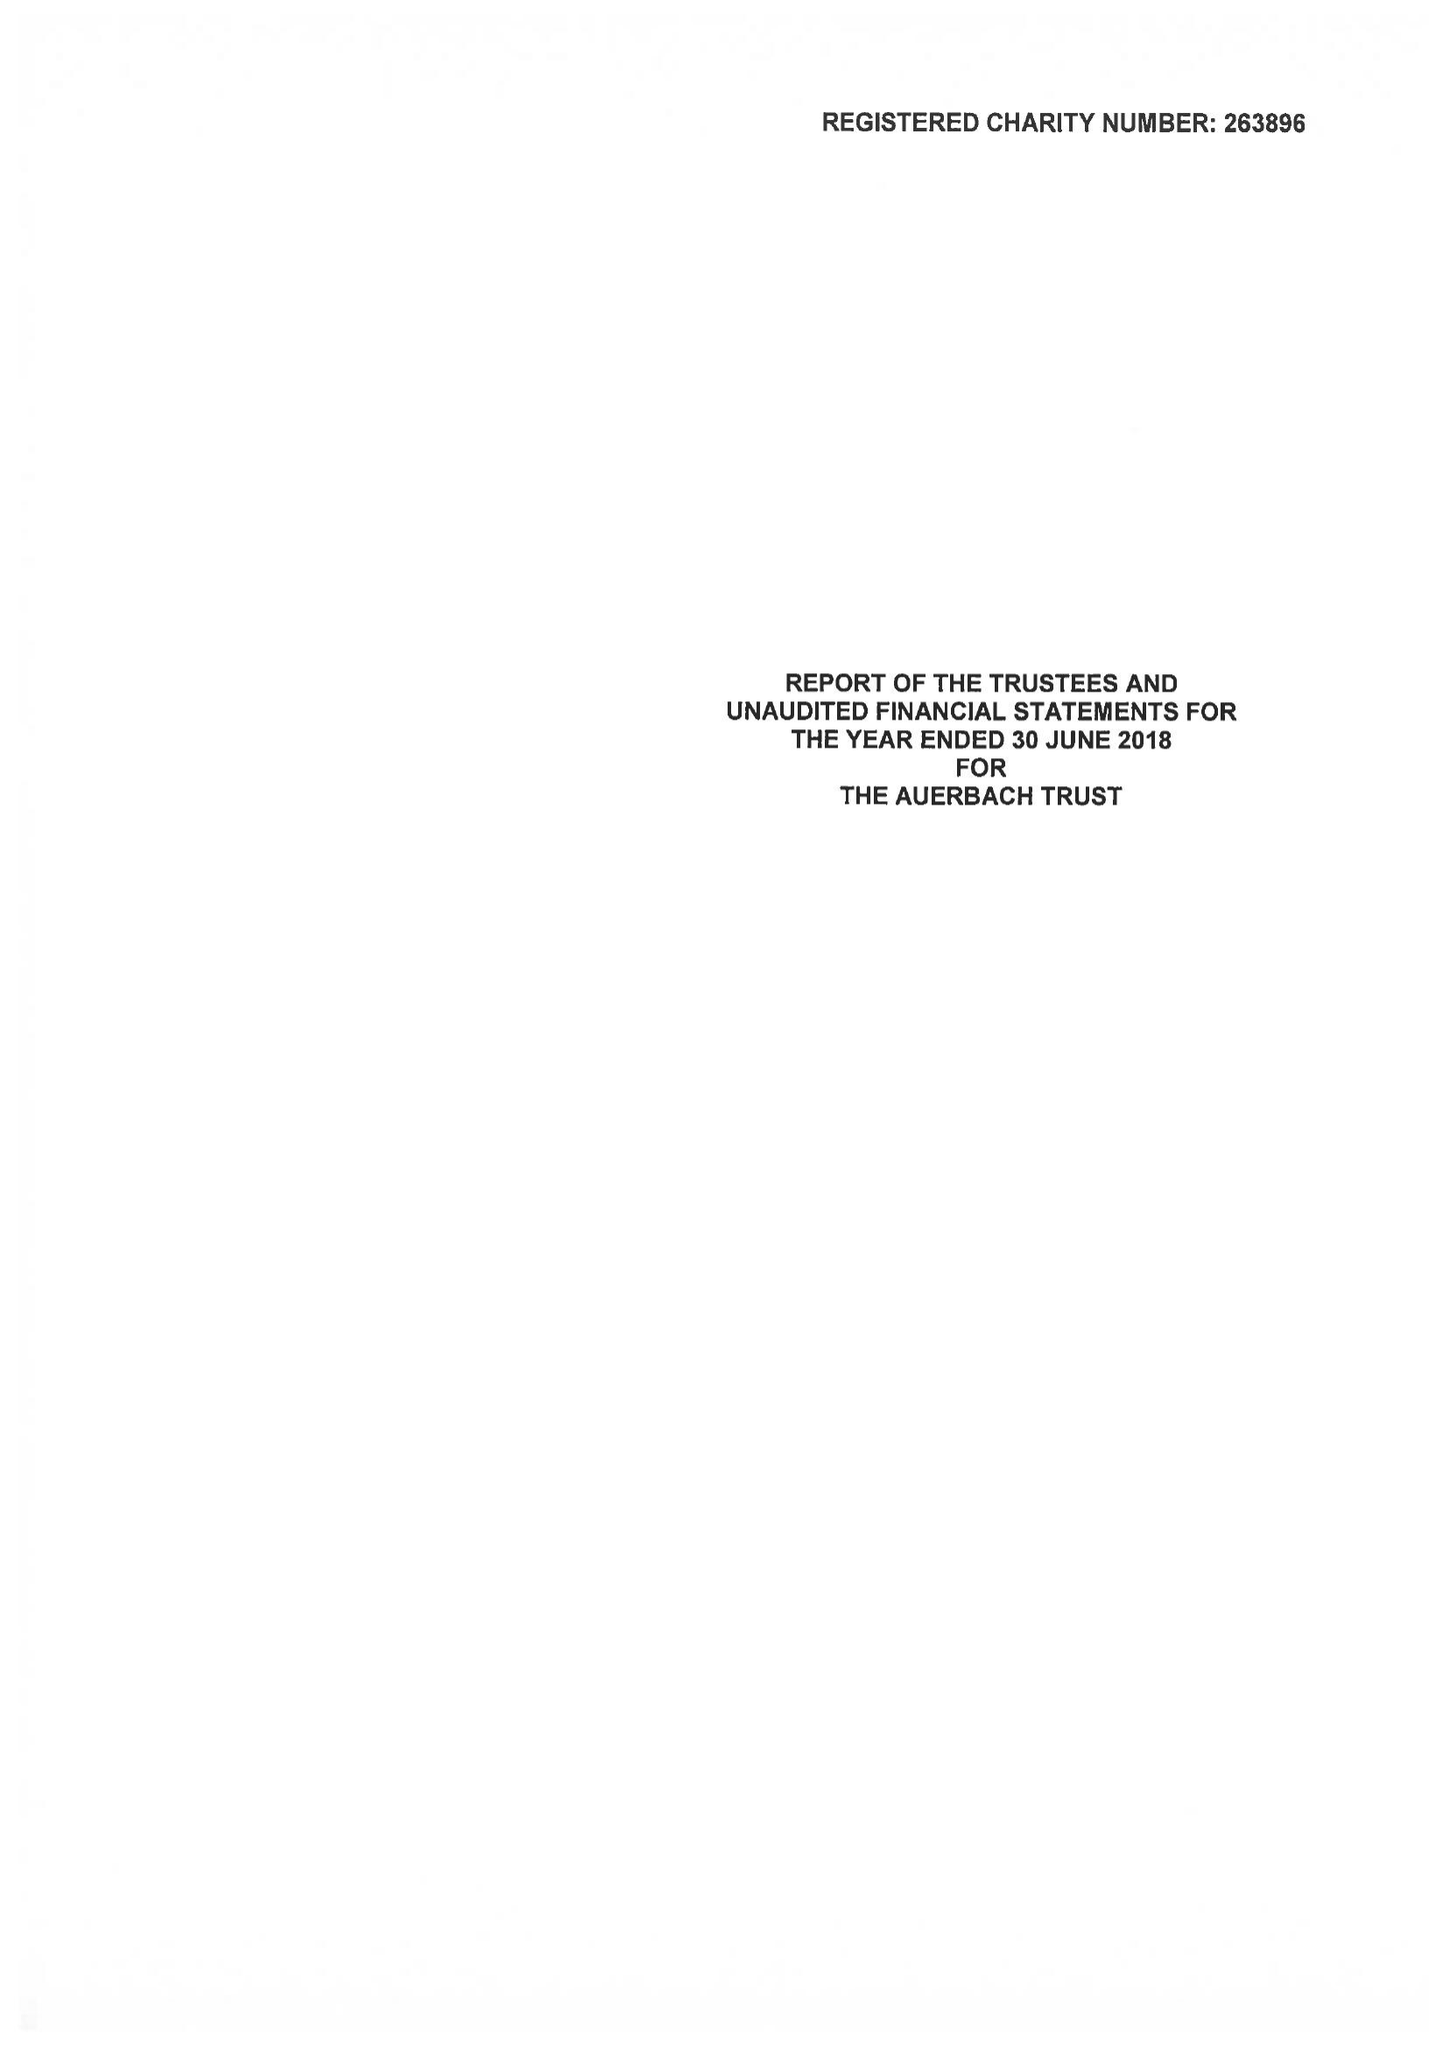What is the value for the charity_name?
Answer the question using a single word or phrase. The Auerbach Trust 